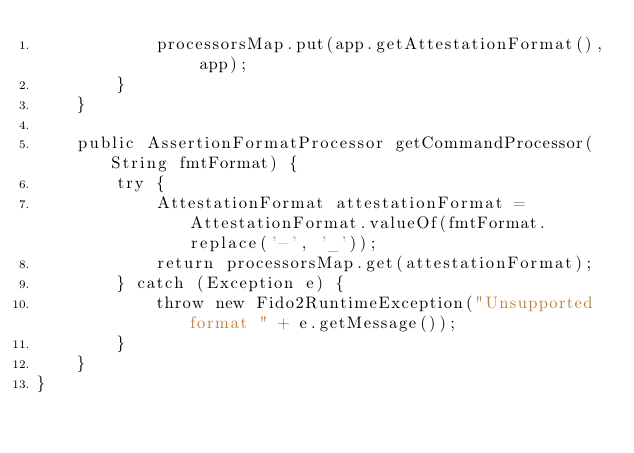Convert code to text. <code><loc_0><loc_0><loc_500><loc_500><_Java_>            processorsMap.put(app.getAttestationFormat(), app);
        }
    }

    public AssertionFormatProcessor getCommandProcessor(String fmtFormat) {
        try {
            AttestationFormat attestationFormat = AttestationFormat.valueOf(fmtFormat.replace('-', '_'));
            return processorsMap.get(attestationFormat);
        } catch (Exception e) {
            throw new Fido2RuntimeException("Unsupported format " + e.getMessage());
        }
    }
}
</code> 